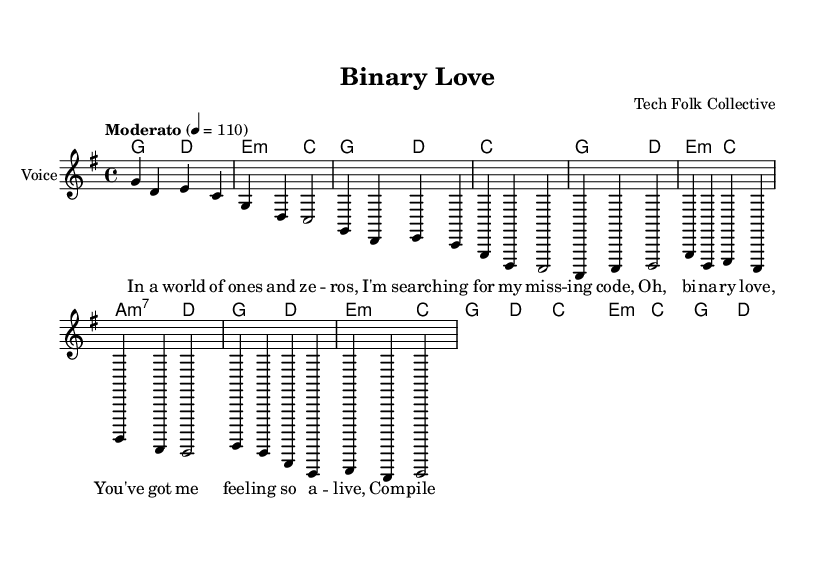What is the key signature of this music? The key signature is G major, which has one sharp (F#) indicated at the beginning of the staff.
Answer: G major What is the time signature of the piece? The time signature is indicated as 4/4, which means there are four beats in each measure.
Answer: 4/4 What is the tempo marking for this piece? The tempo marking is "Moderato," suggesting a moderate pace, typically between 108 to 120 beats per minute. In this case, it specifically indicates a speed of 110 beats per minute.
Answer: Moderato How many measures are in the chorus? The chorus has 4 measures, each consisting of 4 beats, shown as the repeated melodic and harmonic structure following the verse.
Answer: 4 Which chord follows the A minor chord in the verse? After the A minor chord, a D major chord follows, as noted in the chord changes that accompany the melody of the verse.
Answer: D What is the overall theme of the lyrics? The overall theme revolves around love and coding, reflecting the metaphor of a relationship represented in programming terms like binary and compiling.
Answer: Love and coding How many times does the melody repeat in the verse? The melody in the verse repeats twice, indicated by the format and structure of the music notation.
Answer: Twice 